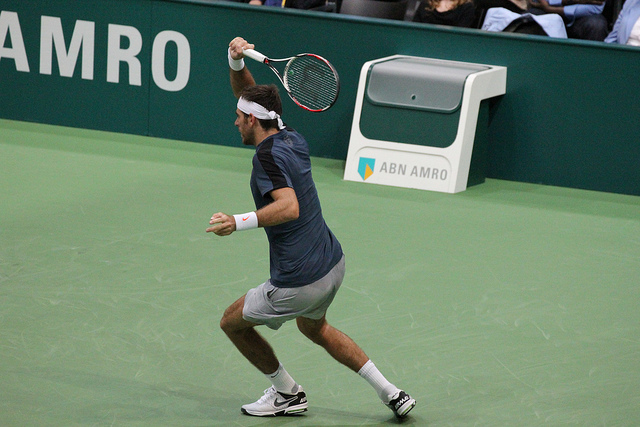This looks like a professional event. Can you speculate on the level of this competition? Given the professional setup and ABN AMRO's sponsorship presence, it's likely this photo is from a high-level competitive event, such as an ATP Tour or an international tournament. These events typically feature top-ranked professionals and are held in venues equipped with sponsor signage, professional lighting, and spectator seating. What kind of surface are they playing on? The court surface in the photo looks to be a hardcourt, identifiable by its flat, uniform appearance. This type of surface is common for indoor events and provides a predictable bounce, suitable for a varied style of play and appealing for both baseline and serve-and-volley players. 